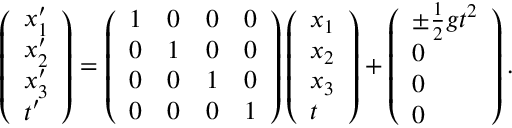Convert formula to latex. <formula><loc_0><loc_0><loc_500><loc_500>\begin{array} { r } { \left ( \begin{array} { l } { x _ { 1 } ^ { \prime } } \\ { x _ { 2 } ^ { \prime } } \\ { x _ { 3 } ^ { \prime } } \\ { t ^ { \prime } } \end{array} \right ) = \left ( \begin{array} { l l l l } { 1 } & { 0 } & { 0 } & { 0 } \\ { 0 } & { 1 } & { 0 } & { 0 } \\ { 0 } & { 0 } & { 1 } & { 0 } \\ { 0 } & { 0 } & { 0 } & { 1 } \end{array} \right ) \left ( \begin{array} { l } { x _ { 1 } } \\ { x _ { 2 } } \\ { x _ { 3 } } \\ { t } \end{array} \right ) + \left ( \begin{array} { l } { \pm \frac { 1 } { 2 } g t ^ { 2 } } \\ { 0 } \\ { 0 } \\ { 0 } \end{array} \right ) . } \end{array}</formula> 